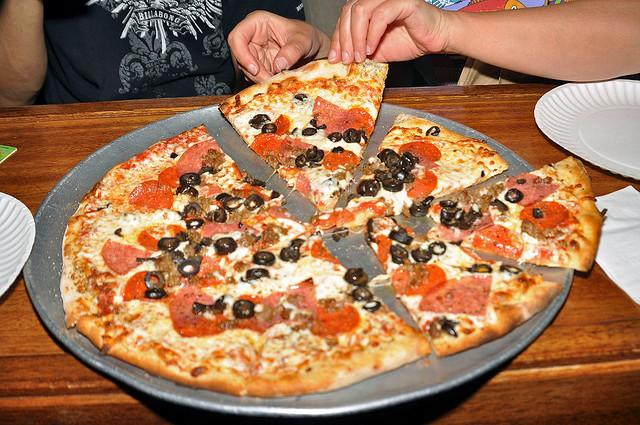How many slices are cut from the pizza?
Short answer required. 4. What was the pizza served on?
Keep it brief. Pan. Which ingredients are on the pizza?
Short answer required. Pepperoni, olives, sausage. 